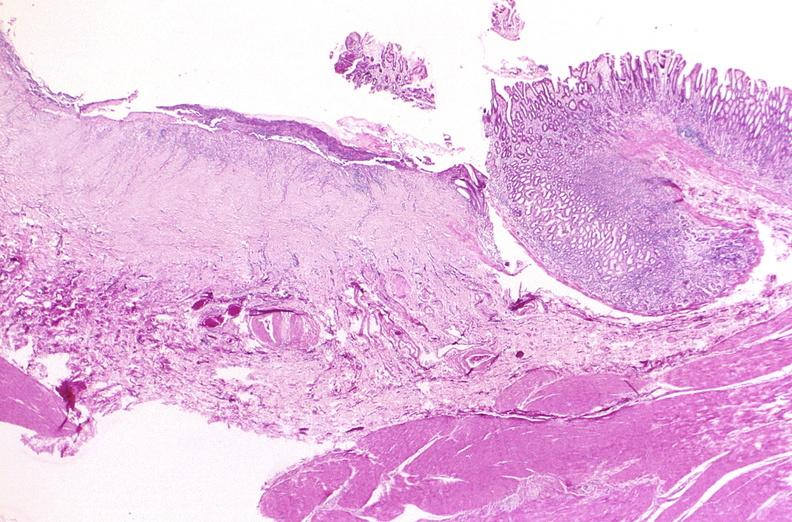s gastrointestinal present?
Answer the question using a single word or phrase. Yes 